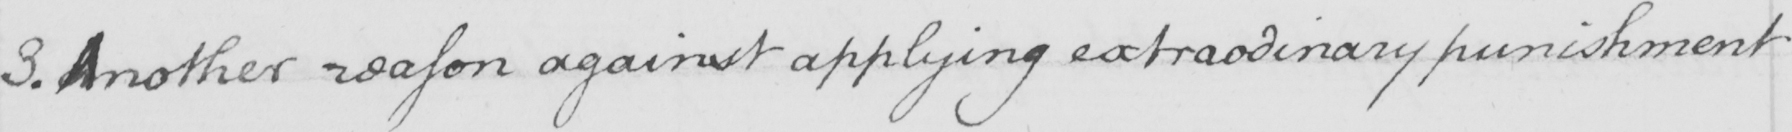What does this handwritten line say? 3 . Another reason against applying extraodinary punishment 